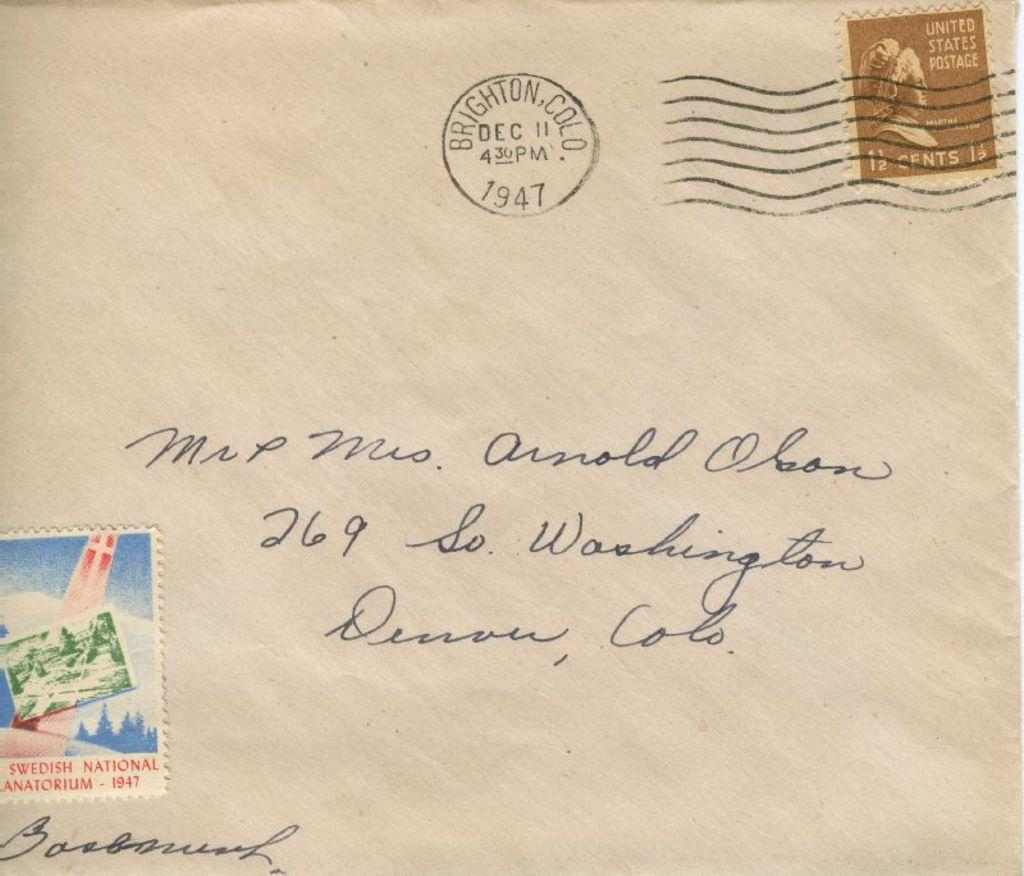<image>
Present a compact description of the photo's key features. An old envelope addressed to Arnold Olson with a 1 1/2 cents stamp. 